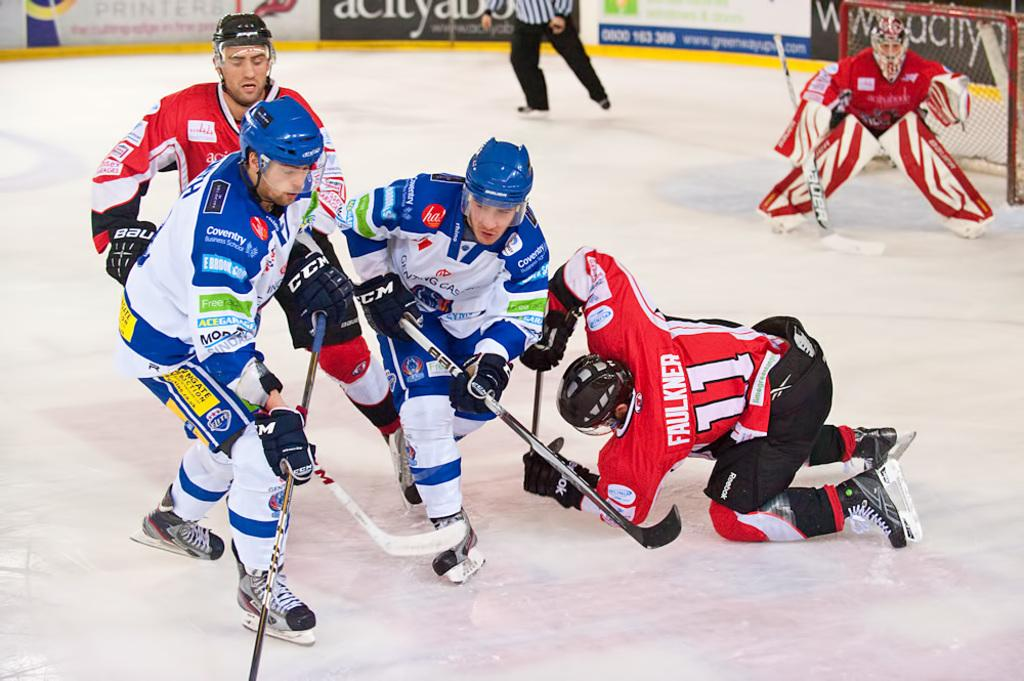Provide a one-sentence caption for the provided image. Faulkner is the hockey player who is falling down during the skirmish. 